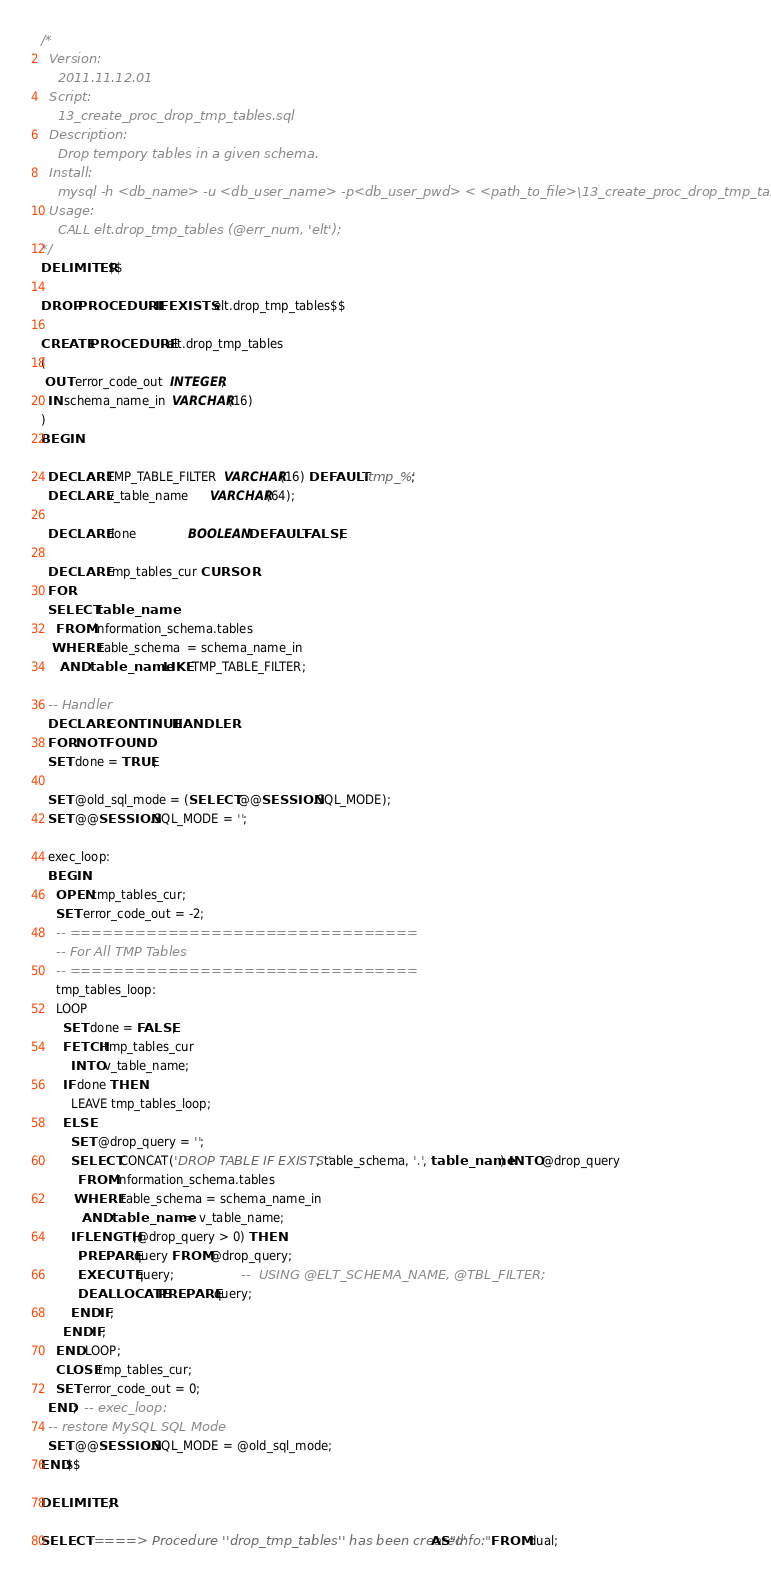Convert code to text. <code><loc_0><loc_0><loc_500><loc_500><_SQL_>/*
  Version:
    2011.11.12.01
  Script:
    13_create_proc_drop_tmp_tables.sql
  Description:
    Drop tempory tables in a given schema.
  Install:
    mysql -h <db_name> -u <db_user_name> -p<db_user_pwd> < <path_to_file>\13_create_proc_drop_tmp_tables.sql
  Usage:
    CALL elt.drop_tmp_tables (@err_num, 'elt');
*/
DELIMITER $$

DROP PROCEDURE IF EXISTS elt.drop_tmp_tables$$

CREATE PROCEDURE elt.drop_tmp_tables
( 
 OUT error_code_out  INTEGER,
  IN schema_name_in  VARCHAR(16)
)
BEGIN

  DECLARE TMP_TABLE_FILTER  VARCHAR(16) DEFAULT 'tmp_%';
  DECLARE v_table_name      VARCHAR(64); 
  
  DECLARE done              BOOLEAN DEFAULT FALSE;
  
  DECLARE tmp_tables_cur CURSOR
  FOR
  SELECT table_name
    FROM information_schema.tables
   WHERE table_schema  = schema_name_in
     AND table_name LIKE TMP_TABLE_FILTER;

  -- Handler
  DECLARE CONTINUE HANDLER
  FOR NOT FOUND
  SET done = TRUE;
  
  SET @old_sql_mode = (SELECT @@SESSION.SQL_MODE);
  SET @@SESSION.SQL_MODE = '';

  exec_loop:
  BEGIN
    OPEN tmp_tables_cur;
    SET error_code_out = -2;
    -- ================================
    -- For All TMP Tables
    -- ================================
    tmp_tables_loop:
    LOOP
      SET done = FALSE;
      FETCH tmp_tables_cur
        INTO v_table_name;
      IF done THEN
        LEAVE tmp_tables_loop;
      ELSE
        SET @drop_query = '';
        SELECT CONCAT('DROP TABLE IF EXISTS ', table_schema, '.', table_name) INTO @drop_query
          FROM information_schema.tables
         WHERE table_schema = schema_name_in
           AND table_name = v_table_name;
        IF LENGTH(@drop_query > 0) THEN
          PREPARE query FROM @drop_query;
          EXECUTE query;                  --  USING @ELT_SCHEMA_NAME, @TBL_FILTER;
          DEALLOCATE PREPARE query; 
        END IF;
      END IF;
    END LOOP;
    CLOSE tmp_tables_cur;
    SET error_code_out = 0;
  END;  -- exec_loop:
  -- restore MySQL SQL Mode 
  SET @@SESSION.SQL_MODE = @old_sql_mode;
END$$

DELIMITER ;

SELECT '====> Procedure ''drop_tmp_tables'' has been created' AS "Info:" FROM dual;
</code> 